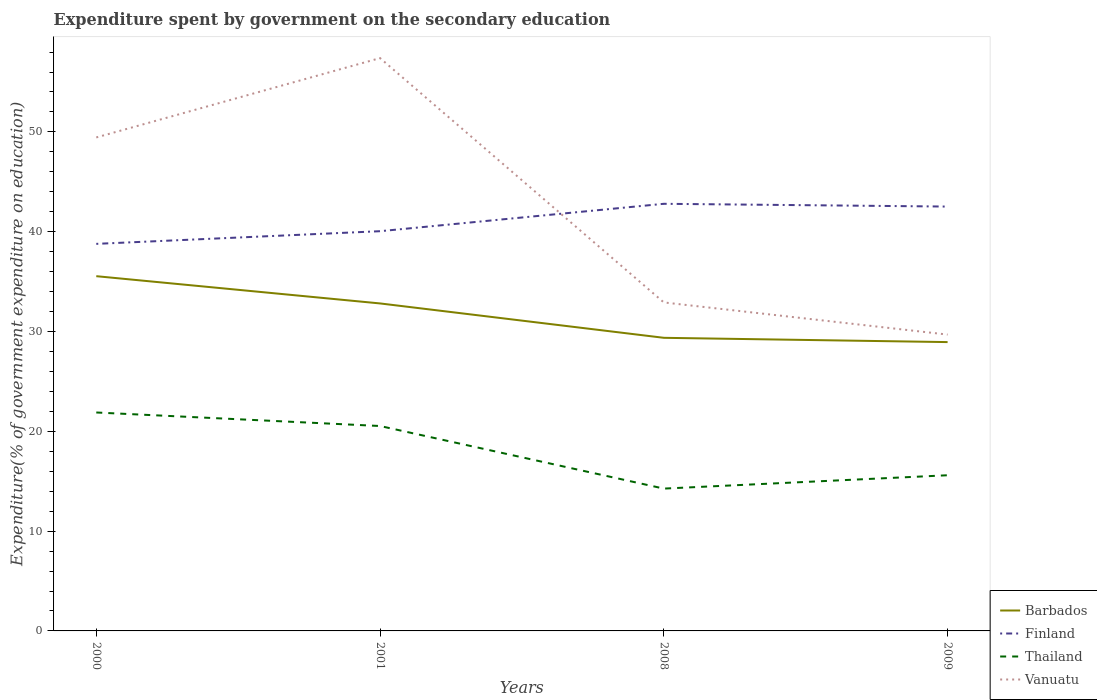Is the number of lines equal to the number of legend labels?
Your response must be concise. Yes. Across all years, what is the maximum expenditure spent by government on the secondary education in Barbados?
Your response must be concise. 28.94. In which year was the expenditure spent by government on the secondary education in Thailand maximum?
Provide a succinct answer. 2008. What is the total expenditure spent by government on the secondary education in Vanuatu in the graph?
Your answer should be very brief. 3.22. What is the difference between the highest and the second highest expenditure spent by government on the secondary education in Finland?
Your answer should be compact. 4.01. What is the difference between the highest and the lowest expenditure spent by government on the secondary education in Thailand?
Ensure brevity in your answer.  2. What is the difference between two consecutive major ticks on the Y-axis?
Ensure brevity in your answer.  10. Are the values on the major ticks of Y-axis written in scientific E-notation?
Your answer should be compact. No. Does the graph contain grids?
Offer a terse response. No. Where does the legend appear in the graph?
Your answer should be compact. Bottom right. What is the title of the graph?
Offer a terse response. Expenditure spent by government on the secondary education. Does "Grenada" appear as one of the legend labels in the graph?
Give a very brief answer. No. What is the label or title of the Y-axis?
Make the answer very short. Expenditure(% of government expenditure on education). What is the Expenditure(% of government expenditure on education) in Barbados in 2000?
Your answer should be very brief. 35.54. What is the Expenditure(% of government expenditure on education) in Finland in 2000?
Provide a succinct answer. 38.78. What is the Expenditure(% of government expenditure on education) in Thailand in 2000?
Your answer should be very brief. 21.89. What is the Expenditure(% of government expenditure on education) in Vanuatu in 2000?
Provide a succinct answer. 49.45. What is the Expenditure(% of government expenditure on education) in Barbados in 2001?
Give a very brief answer. 32.81. What is the Expenditure(% of government expenditure on education) of Finland in 2001?
Make the answer very short. 40.05. What is the Expenditure(% of government expenditure on education) of Thailand in 2001?
Give a very brief answer. 20.53. What is the Expenditure(% of government expenditure on education) in Vanuatu in 2001?
Provide a succinct answer. 57.4. What is the Expenditure(% of government expenditure on education) of Barbados in 2008?
Your answer should be compact. 29.37. What is the Expenditure(% of government expenditure on education) in Finland in 2008?
Your response must be concise. 42.8. What is the Expenditure(% of government expenditure on education) in Thailand in 2008?
Offer a very short reply. 14.26. What is the Expenditure(% of government expenditure on education) of Vanuatu in 2008?
Provide a short and direct response. 32.91. What is the Expenditure(% of government expenditure on education) in Barbados in 2009?
Make the answer very short. 28.94. What is the Expenditure(% of government expenditure on education) in Finland in 2009?
Give a very brief answer. 42.52. What is the Expenditure(% of government expenditure on education) of Thailand in 2009?
Your response must be concise. 15.6. What is the Expenditure(% of government expenditure on education) in Vanuatu in 2009?
Give a very brief answer. 29.69. Across all years, what is the maximum Expenditure(% of government expenditure on education) in Barbados?
Ensure brevity in your answer.  35.54. Across all years, what is the maximum Expenditure(% of government expenditure on education) in Finland?
Give a very brief answer. 42.8. Across all years, what is the maximum Expenditure(% of government expenditure on education) in Thailand?
Ensure brevity in your answer.  21.89. Across all years, what is the maximum Expenditure(% of government expenditure on education) of Vanuatu?
Ensure brevity in your answer.  57.4. Across all years, what is the minimum Expenditure(% of government expenditure on education) of Barbados?
Provide a short and direct response. 28.94. Across all years, what is the minimum Expenditure(% of government expenditure on education) of Finland?
Keep it short and to the point. 38.78. Across all years, what is the minimum Expenditure(% of government expenditure on education) of Thailand?
Your answer should be compact. 14.26. Across all years, what is the minimum Expenditure(% of government expenditure on education) in Vanuatu?
Your answer should be very brief. 29.69. What is the total Expenditure(% of government expenditure on education) of Barbados in the graph?
Your response must be concise. 126.67. What is the total Expenditure(% of government expenditure on education) of Finland in the graph?
Make the answer very short. 164.15. What is the total Expenditure(% of government expenditure on education) in Thailand in the graph?
Ensure brevity in your answer.  72.28. What is the total Expenditure(% of government expenditure on education) of Vanuatu in the graph?
Ensure brevity in your answer.  169.45. What is the difference between the Expenditure(% of government expenditure on education) in Barbados in 2000 and that in 2001?
Your answer should be compact. 2.73. What is the difference between the Expenditure(% of government expenditure on education) of Finland in 2000 and that in 2001?
Offer a terse response. -1.27. What is the difference between the Expenditure(% of government expenditure on education) in Thailand in 2000 and that in 2001?
Give a very brief answer. 1.35. What is the difference between the Expenditure(% of government expenditure on education) in Vanuatu in 2000 and that in 2001?
Offer a terse response. -7.95. What is the difference between the Expenditure(% of government expenditure on education) in Barbados in 2000 and that in 2008?
Your answer should be very brief. 6.18. What is the difference between the Expenditure(% of government expenditure on education) of Finland in 2000 and that in 2008?
Your answer should be very brief. -4.01. What is the difference between the Expenditure(% of government expenditure on education) in Thailand in 2000 and that in 2008?
Give a very brief answer. 7.63. What is the difference between the Expenditure(% of government expenditure on education) of Vanuatu in 2000 and that in 2008?
Offer a very short reply. 16.53. What is the difference between the Expenditure(% of government expenditure on education) in Barbados in 2000 and that in 2009?
Give a very brief answer. 6.6. What is the difference between the Expenditure(% of government expenditure on education) of Finland in 2000 and that in 2009?
Offer a terse response. -3.74. What is the difference between the Expenditure(% of government expenditure on education) in Thailand in 2000 and that in 2009?
Keep it short and to the point. 6.29. What is the difference between the Expenditure(% of government expenditure on education) of Vanuatu in 2000 and that in 2009?
Provide a short and direct response. 19.75. What is the difference between the Expenditure(% of government expenditure on education) in Barbados in 2001 and that in 2008?
Your response must be concise. 3.44. What is the difference between the Expenditure(% of government expenditure on education) of Finland in 2001 and that in 2008?
Keep it short and to the point. -2.74. What is the difference between the Expenditure(% of government expenditure on education) of Thailand in 2001 and that in 2008?
Your answer should be compact. 6.27. What is the difference between the Expenditure(% of government expenditure on education) in Vanuatu in 2001 and that in 2008?
Your answer should be very brief. 24.48. What is the difference between the Expenditure(% of government expenditure on education) of Barbados in 2001 and that in 2009?
Provide a short and direct response. 3.87. What is the difference between the Expenditure(% of government expenditure on education) of Finland in 2001 and that in 2009?
Make the answer very short. -2.47. What is the difference between the Expenditure(% of government expenditure on education) in Thailand in 2001 and that in 2009?
Your answer should be very brief. 4.93. What is the difference between the Expenditure(% of government expenditure on education) in Vanuatu in 2001 and that in 2009?
Keep it short and to the point. 27.7. What is the difference between the Expenditure(% of government expenditure on education) in Barbados in 2008 and that in 2009?
Offer a terse response. 0.43. What is the difference between the Expenditure(% of government expenditure on education) of Finland in 2008 and that in 2009?
Make the answer very short. 0.28. What is the difference between the Expenditure(% of government expenditure on education) in Thailand in 2008 and that in 2009?
Provide a short and direct response. -1.34. What is the difference between the Expenditure(% of government expenditure on education) of Vanuatu in 2008 and that in 2009?
Give a very brief answer. 3.22. What is the difference between the Expenditure(% of government expenditure on education) in Barbados in 2000 and the Expenditure(% of government expenditure on education) in Finland in 2001?
Provide a succinct answer. -4.51. What is the difference between the Expenditure(% of government expenditure on education) in Barbados in 2000 and the Expenditure(% of government expenditure on education) in Thailand in 2001?
Your answer should be very brief. 15.01. What is the difference between the Expenditure(% of government expenditure on education) in Barbados in 2000 and the Expenditure(% of government expenditure on education) in Vanuatu in 2001?
Give a very brief answer. -21.85. What is the difference between the Expenditure(% of government expenditure on education) in Finland in 2000 and the Expenditure(% of government expenditure on education) in Thailand in 2001?
Your answer should be very brief. 18.25. What is the difference between the Expenditure(% of government expenditure on education) in Finland in 2000 and the Expenditure(% of government expenditure on education) in Vanuatu in 2001?
Your response must be concise. -18.61. What is the difference between the Expenditure(% of government expenditure on education) of Thailand in 2000 and the Expenditure(% of government expenditure on education) of Vanuatu in 2001?
Give a very brief answer. -35.51. What is the difference between the Expenditure(% of government expenditure on education) of Barbados in 2000 and the Expenditure(% of government expenditure on education) of Finland in 2008?
Provide a short and direct response. -7.25. What is the difference between the Expenditure(% of government expenditure on education) of Barbados in 2000 and the Expenditure(% of government expenditure on education) of Thailand in 2008?
Give a very brief answer. 21.28. What is the difference between the Expenditure(% of government expenditure on education) of Barbados in 2000 and the Expenditure(% of government expenditure on education) of Vanuatu in 2008?
Give a very brief answer. 2.63. What is the difference between the Expenditure(% of government expenditure on education) in Finland in 2000 and the Expenditure(% of government expenditure on education) in Thailand in 2008?
Give a very brief answer. 24.52. What is the difference between the Expenditure(% of government expenditure on education) of Finland in 2000 and the Expenditure(% of government expenditure on education) of Vanuatu in 2008?
Provide a short and direct response. 5.87. What is the difference between the Expenditure(% of government expenditure on education) of Thailand in 2000 and the Expenditure(% of government expenditure on education) of Vanuatu in 2008?
Give a very brief answer. -11.03. What is the difference between the Expenditure(% of government expenditure on education) in Barbados in 2000 and the Expenditure(% of government expenditure on education) in Finland in 2009?
Provide a short and direct response. -6.97. What is the difference between the Expenditure(% of government expenditure on education) in Barbados in 2000 and the Expenditure(% of government expenditure on education) in Thailand in 2009?
Your response must be concise. 19.95. What is the difference between the Expenditure(% of government expenditure on education) of Barbados in 2000 and the Expenditure(% of government expenditure on education) of Vanuatu in 2009?
Provide a succinct answer. 5.85. What is the difference between the Expenditure(% of government expenditure on education) of Finland in 2000 and the Expenditure(% of government expenditure on education) of Thailand in 2009?
Your response must be concise. 23.18. What is the difference between the Expenditure(% of government expenditure on education) in Finland in 2000 and the Expenditure(% of government expenditure on education) in Vanuatu in 2009?
Offer a very short reply. 9.09. What is the difference between the Expenditure(% of government expenditure on education) in Thailand in 2000 and the Expenditure(% of government expenditure on education) in Vanuatu in 2009?
Give a very brief answer. -7.81. What is the difference between the Expenditure(% of government expenditure on education) in Barbados in 2001 and the Expenditure(% of government expenditure on education) in Finland in 2008?
Offer a terse response. -9.98. What is the difference between the Expenditure(% of government expenditure on education) of Barbados in 2001 and the Expenditure(% of government expenditure on education) of Thailand in 2008?
Make the answer very short. 18.55. What is the difference between the Expenditure(% of government expenditure on education) in Barbados in 2001 and the Expenditure(% of government expenditure on education) in Vanuatu in 2008?
Your response must be concise. -0.1. What is the difference between the Expenditure(% of government expenditure on education) in Finland in 2001 and the Expenditure(% of government expenditure on education) in Thailand in 2008?
Offer a terse response. 25.79. What is the difference between the Expenditure(% of government expenditure on education) in Finland in 2001 and the Expenditure(% of government expenditure on education) in Vanuatu in 2008?
Ensure brevity in your answer.  7.14. What is the difference between the Expenditure(% of government expenditure on education) of Thailand in 2001 and the Expenditure(% of government expenditure on education) of Vanuatu in 2008?
Ensure brevity in your answer.  -12.38. What is the difference between the Expenditure(% of government expenditure on education) in Barbados in 2001 and the Expenditure(% of government expenditure on education) in Finland in 2009?
Keep it short and to the point. -9.71. What is the difference between the Expenditure(% of government expenditure on education) in Barbados in 2001 and the Expenditure(% of government expenditure on education) in Thailand in 2009?
Make the answer very short. 17.22. What is the difference between the Expenditure(% of government expenditure on education) in Barbados in 2001 and the Expenditure(% of government expenditure on education) in Vanuatu in 2009?
Offer a very short reply. 3.12. What is the difference between the Expenditure(% of government expenditure on education) in Finland in 2001 and the Expenditure(% of government expenditure on education) in Thailand in 2009?
Your response must be concise. 24.45. What is the difference between the Expenditure(% of government expenditure on education) in Finland in 2001 and the Expenditure(% of government expenditure on education) in Vanuatu in 2009?
Provide a short and direct response. 10.36. What is the difference between the Expenditure(% of government expenditure on education) in Thailand in 2001 and the Expenditure(% of government expenditure on education) in Vanuatu in 2009?
Keep it short and to the point. -9.16. What is the difference between the Expenditure(% of government expenditure on education) of Barbados in 2008 and the Expenditure(% of government expenditure on education) of Finland in 2009?
Offer a very short reply. -13.15. What is the difference between the Expenditure(% of government expenditure on education) in Barbados in 2008 and the Expenditure(% of government expenditure on education) in Thailand in 2009?
Offer a terse response. 13.77. What is the difference between the Expenditure(% of government expenditure on education) of Barbados in 2008 and the Expenditure(% of government expenditure on education) of Vanuatu in 2009?
Your answer should be very brief. -0.32. What is the difference between the Expenditure(% of government expenditure on education) in Finland in 2008 and the Expenditure(% of government expenditure on education) in Thailand in 2009?
Your answer should be very brief. 27.2. What is the difference between the Expenditure(% of government expenditure on education) in Finland in 2008 and the Expenditure(% of government expenditure on education) in Vanuatu in 2009?
Offer a terse response. 13.1. What is the difference between the Expenditure(% of government expenditure on education) of Thailand in 2008 and the Expenditure(% of government expenditure on education) of Vanuatu in 2009?
Your answer should be very brief. -15.43. What is the average Expenditure(% of government expenditure on education) of Barbados per year?
Keep it short and to the point. 31.67. What is the average Expenditure(% of government expenditure on education) of Finland per year?
Provide a succinct answer. 41.04. What is the average Expenditure(% of government expenditure on education) in Thailand per year?
Offer a terse response. 18.07. What is the average Expenditure(% of government expenditure on education) in Vanuatu per year?
Ensure brevity in your answer.  42.36. In the year 2000, what is the difference between the Expenditure(% of government expenditure on education) of Barbados and Expenditure(% of government expenditure on education) of Finland?
Ensure brevity in your answer.  -3.24. In the year 2000, what is the difference between the Expenditure(% of government expenditure on education) in Barbados and Expenditure(% of government expenditure on education) in Thailand?
Your answer should be very brief. 13.66. In the year 2000, what is the difference between the Expenditure(% of government expenditure on education) of Barbados and Expenditure(% of government expenditure on education) of Vanuatu?
Provide a succinct answer. -13.9. In the year 2000, what is the difference between the Expenditure(% of government expenditure on education) in Finland and Expenditure(% of government expenditure on education) in Thailand?
Provide a short and direct response. 16.9. In the year 2000, what is the difference between the Expenditure(% of government expenditure on education) in Finland and Expenditure(% of government expenditure on education) in Vanuatu?
Provide a succinct answer. -10.66. In the year 2000, what is the difference between the Expenditure(% of government expenditure on education) in Thailand and Expenditure(% of government expenditure on education) in Vanuatu?
Give a very brief answer. -27.56. In the year 2001, what is the difference between the Expenditure(% of government expenditure on education) in Barbados and Expenditure(% of government expenditure on education) in Finland?
Ensure brevity in your answer.  -7.24. In the year 2001, what is the difference between the Expenditure(% of government expenditure on education) of Barbados and Expenditure(% of government expenditure on education) of Thailand?
Ensure brevity in your answer.  12.28. In the year 2001, what is the difference between the Expenditure(% of government expenditure on education) of Barbados and Expenditure(% of government expenditure on education) of Vanuatu?
Provide a succinct answer. -24.58. In the year 2001, what is the difference between the Expenditure(% of government expenditure on education) of Finland and Expenditure(% of government expenditure on education) of Thailand?
Offer a very short reply. 19.52. In the year 2001, what is the difference between the Expenditure(% of government expenditure on education) of Finland and Expenditure(% of government expenditure on education) of Vanuatu?
Your answer should be very brief. -17.34. In the year 2001, what is the difference between the Expenditure(% of government expenditure on education) of Thailand and Expenditure(% of government expenditure on education) of Vanuatu?
Give a very brief answer. -36.86. In the year 2008, what is the difference between the Expenditure(% of government expenditure on education) of Barbados and Expenditure(% of government expenditure on education) of Finland?
Keep it short and to the point. -13.43. In the year 2008, what is the difference between the Expenditure(% of government expenditure on education) in Barbados and Expenditure(% of government expenditure on education) in Thailand?
Ensure brevity in your answer.  15.11. In the year 2008, what is the difference between the Expenditure(% of government expenditure on education) of Barbados and Expenditure(% of government expenditure on education) of Vanuatu?
Your answer should be compact. -3.54. In the year 2008, what is the difference between the Expenditure(% of government expenditure on education) of Finland and Expenditure(% of government expenditure on education) of Thailand?
Your answer should be compact. 28.54. In the year 2008, what is the difference between the Expenditure(% of government expenditure on education) of Finland and Expenditure(% of government expenditure on education) of Vanuatu?
Your answer should be very brief. 9.88. In the year 2008, what is the difference between the Expenditure(% of government expenditure on education) of Thailand and Expenditure(% of government expenditure on education) of Vanuatu?
Provide a short and direct response. -18.65. In the year 2009, what is the difference between the Expenditure(% of government expenditure on education) of Barbados and Expenditure(% of government expenditure on education) of Finland?
Offer a terse response. -13.58. In the year 2009, what is the difference between the Expenditure(% of government expenditure on education) in Barbados and Expenditure(% of government expenditure on education) in Thailand?
Ensure brevity in your answer.  13.34. In the year 2009, what is the difference between the Expenditure(% of government expenditure on education) of Barbados and Expenditure(% of government expenditure on education) of Vanuatu?
Make the answer very short. -0.75. In the year 2009, what is the difference between the Expenditure(% of government expenditure on education) of Finland and Expenditure(% of government expenditure on education) of Thailand?
Provide a short and direct response. 26.92. In the year 2009, what is the difference between the Expenditure(% of government expenditure on education) in Finland and Expenditure(% of government expenditure on education) in Vanuatu?
Your answer should be compact. 12.83. In the year 2009, what is the difference between the Expenditure(% of government expenditure on education) of Thailand and Expenditure(% of government expenditure on education) of Vanuatu?
Provide a succinct answer. -14.09. What is the ratio of the Expenditure(% of government expenditure on education) of Barbados in 2000 to that in 2001?
Keep it short and to the point. 1.08. What is the ratio of the Expenditure(% of government expenditure on education) in Finland in 2000 to that in 2001?
Provide a succinct answer. 0.97. What is the ratio of the Expenditure(% of government expenditure on education) of Thailand in 2000 to that in 2001?
Your answer should be compact. 1.07. What is the ratio of the Expenditure(% of government expenditure on education) in Vanuatu in 2000 to that in 2001?
Your answer should be compact. 0.86. What is the ratio of the Expenditure(% of government expenditure on education) in Barbados in 2000 to that in 2008?
Ensure brevity in your answer.  1.21. What is the ratio of the Expenditure(% of government expenditure on education) of Finland in 2000 to that in 2008?
Your response must be concise. 0.91. What is the ratio of the Expenditure(% of government expenditure on education) of Thailand in 2000 to that in 2008?
Provide a short and direct response. 1.53. What is the ratio of the Expenditure(% of government expenditure on education) of Vanuatu in 2000 to that in 2008?
Offer a very short reply. 1.5. What is the ratio of the Expenditure(% of government expenditure on education) of Barbados in 2000 to that in 2009?
Provide a short and direct response. 1.23. What is the ratio of the Expenditure(% of government expenditure on education) in Finland in 2000 to that in 2009?
Offer a terse response. 0.91. What is the ratio of the Expenditure(% of government expenditure on education) of Thailand in 2000 to that in 2009?
Your answer should be compact. 1.4. What is the ratio of the Expenditure(% of government expenditure on education) of Vanuatu in 2000 to that in 2009?
Make the answer very short. 1.67. What is the ratio of the Expenditure(% of government expenditure on education) of Barbados in 2001 to that in 2008?
Your response must be concise. 1.12. What is the ratio of the Expenditure(% of government expenditure on education) in Finland in 2001 to that in 2008?
Ensure brevity in your answer.  0.94. What is the ratio of the Expenditure(% of government expenditure on education) in Thailand in 2001 to that in 2008?
Your response must be concise. 1.44. What is the ratio of the Expenditure(% of government expenditure on education) in Vanuatu in 2001 to that in 2008?
Your response must be concise. 1.74. What is the ratio of the Expenditure(% of government expenditure on education) in Barbados in 2001 to that in 2009?
Your answer should be compact. 1.13. What is the ratio of the Expenditure(% of government expenditure on education) of Finland in 2001 to that in 2009?
Offer a terse response. 0.94. What is the ratio of the Expenditure(% of government expenditure on education) in Thailand in 2001 to that in 2009?
Your answer should be very brief. 1.32. What is the ratio of the Expenditure(% of government expenditure on education) of Vanuatu in 2001 to that in 2009?
Offer a terse response. 1.93. What is the ratio of the Expenditure(% of government expenditure on education) in Barbados in 2008 to that in 2009?
Your response must be concise. 1.01. What is the ratio of the Expenditure(% of government expenditure on education) in Thailand in 2008 to that in 2009?
Ensure brevity in your answer.  0.91. What is the ratio of the Expenditure(% of government expenditure on education) in Vanuatu in 2008 to that in 2009?
Provide a succinct answer. 1.11. What is the difference between the highest and the second highest Expenditure(% of government expenditure on education) of Barbados?
Ensure brevity in your answer.  2.73. What is the difference between the highest and the second highest Expenditure(% of government expenditure on education) in Finland?
Your response must be concise. 0.28. What is the difference between the highest and the second highest Expenditure(% of government expenditure on education) in Thailand?
Make the answer very short. 1.35. What is the difference between the highest and the second highest Expenditure(% of government expenditure on education) of Vanuatu?
Offer a very short reply. 7.95. What is the difference between the highest and the lowest Expenditure(% of government expenditure on education) of Barbados?
Provide a short and direct response. 6.6. What is the difference between the highest and the lowest Expenditure(% of government expenditure on education) in Finland?
Your response must be concise. 4.01. What is the difference between the highest and the lowest Expenditure(% of government expenditure on education) of Thailand?
Keep it short and to the point. 7.63. What is the difference between the highest and the lowest Expenditure(% of government expenditure on education) in Vanuatu?
Make the answer very short. 27.7. 